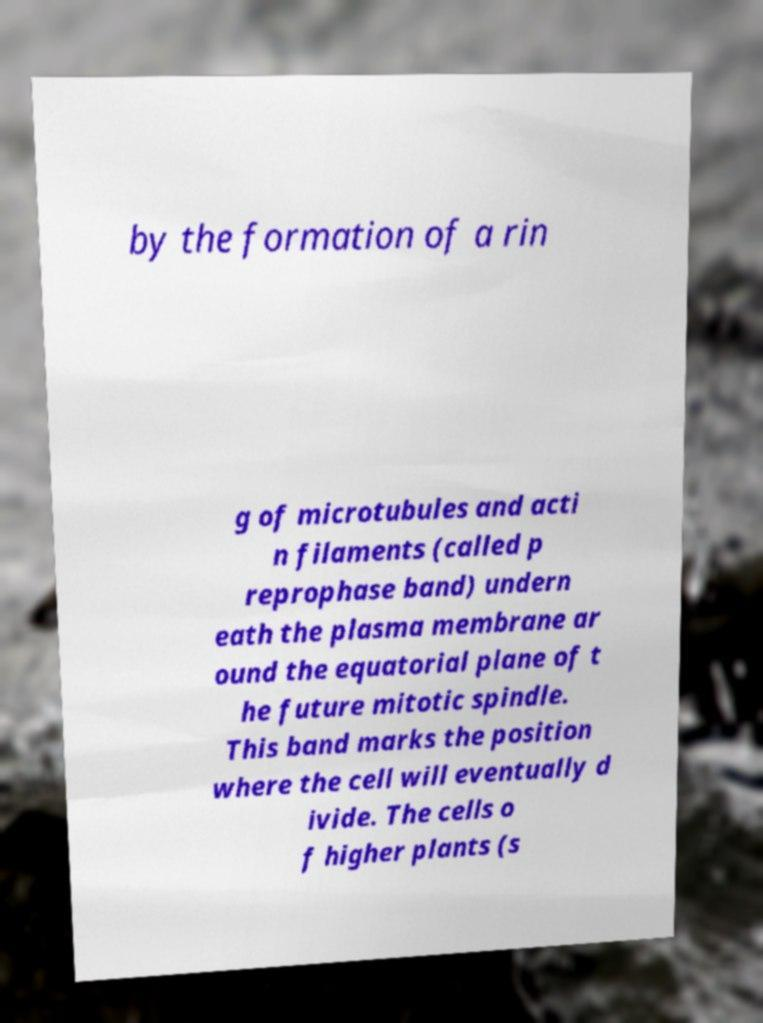There's text embedded in this image that I need extracted. Can you transcribe it verbatim? by the formation of a rin g of microtubules and acti n filaments (called p reprophase band) undern eath the plasma membrane ar ound the equatorial plane of t he future mitotic spindle. This band marks the position where the cell will eventually d ivide. The cells o f higher plants (s 